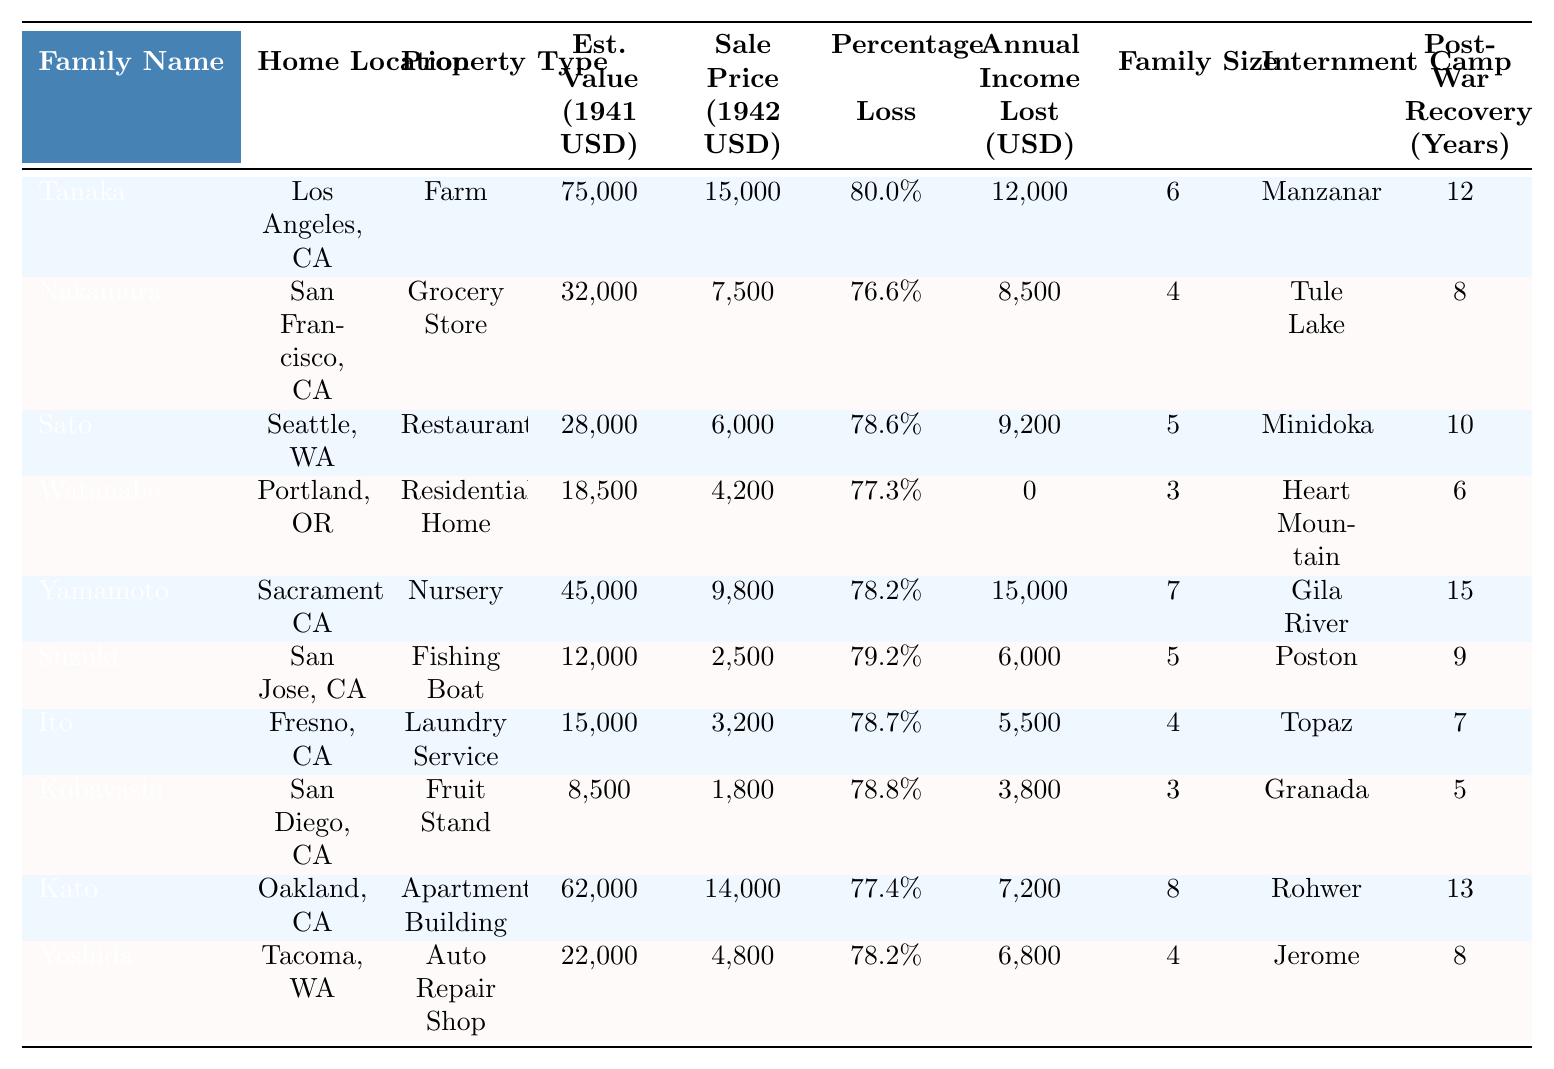What is the estimated value of the Tanaka family's property in 1941? The table lists the estimated value of the Tanaka family's property under the "Est. Value (1941 USD)" column, where it is specified as 75,000.
Answer: 75,000 What was the sale price of the Suzuki family's fishing boat in 1942? By looking at the "Sale Price (1942 USD)" column for the Suzuki family, the sale price is found to be 2,500.
Answer: 2,500 Which family experienced the highest percentage loss of property? The "Percentage Loss" column indicates the percentage loss for the Tanaka family is 80.0%, which is the highest compared to others.
Answer: Tanaka How many family members did the Yamamoto family have? The "Family Size" column lists the Yamamoto family's size as 7.
Answer: 7 What is the average annual income lost for families interned in Tule Lake and Poston? The “Annual Income Lost (USD)” for Tule Lake is 8,500 and for Poston is 6,000. Adding these gives 14,500. Dividing by 2 for the average gives 7,250.
Answer: 7,250 Did the Watanabe family lose any annual income due to property confiscation? According to the "Annual Income Lost (USD)" column, the Watanabe family shows a value of 0, indicating no annual income was lost.
Answer: No What is the total estimated value of all properties listed in the table? Summing the "Est. Value (1941 USD)" column gives: 75,000 + 32,000 + 28,000 + 18,500 + 45,000 + 12,000 + 15,000 + 8,500 + 62,000 + 22,000 =  346,000.
Answer: 346,000 Which internment camp did the largest family (in terms of family size) belong to? The family with the largest size is Kato with 8 members, who were interned at Rohwer.
Answer: Rohwer What percentage loss did the Kato family experience? The "Percentage Loss" for the Kato family in the table is listed as 77.4%.
Answer: 77.4% Which property type had the lowest estimated value in 1941? By reviewing the "Est. Value (1941 USD)" column, the lowest estimated value is for the Kobayashi family with 8,500 for their fruit stand.
Answer: Fruit Stand How many years did the Sato family take to recover post-war? The "Post-War Recovery (Years)" for the Sato family is indicated in the table as 10.
Answer: 10 